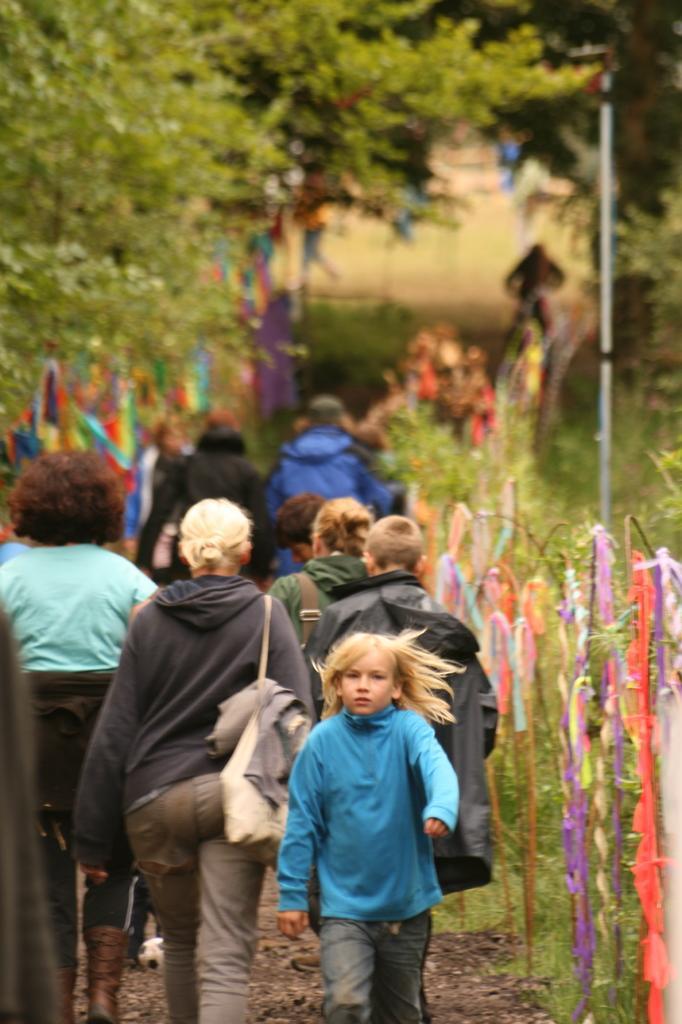Please provide a concise description of this image. This image is clicked outside. There are trees at the top. There are so many persons walking in the middle. 